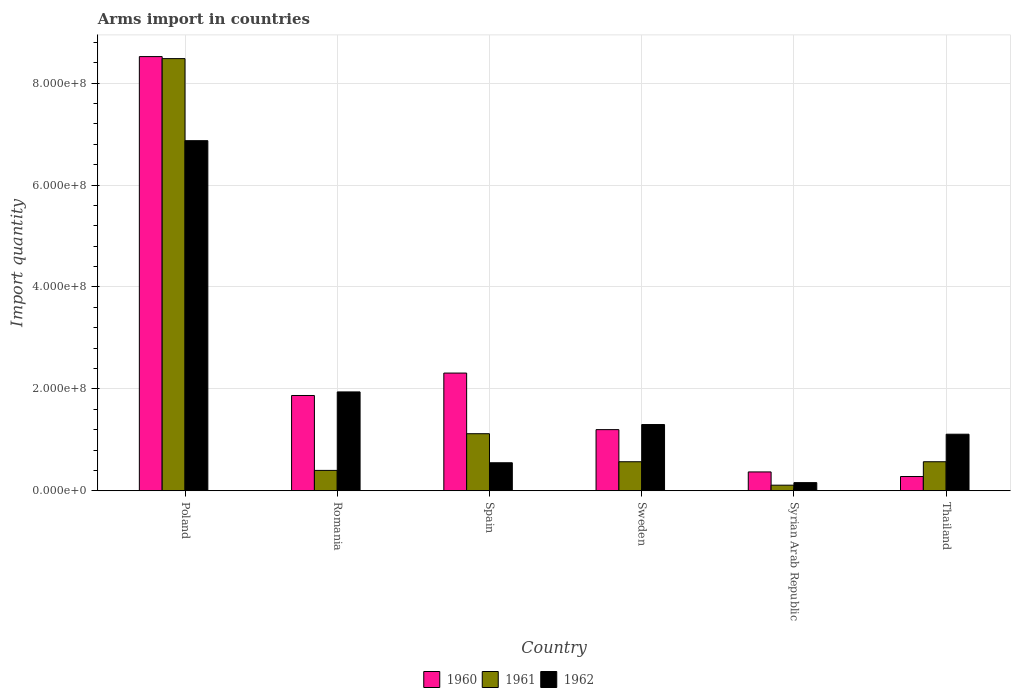How many groups of bars are there?
Your response must be concise. 6. Are the number of bars per tick equal to the number of legend labels?
Offer a very short reply. Yes. Are the number of bars on each tick of the X-axis equal?
Provide a short and direct response. Yes. How many bars are there on the 5th tick from the left?
Your response must be concise. 3. How many bars are there on the 6th tick from the right?
Your answer should be very brief. 3. What is the label of the 6th group of bars from the left?
Offer a very short reply. Thailand. What is the total arms import in 1961 in Syrian Arab Republic?
Your answer should be compact. 1.10e+07. Across all countries, what is the maximum total arms import in 1962?
Offer a terse response. 6.87e+08. Across all countries, what is the minimum total arms import in 1962?
Give a very brief answer. 1.60e+07. In which country was the total arms import in 1961 maximum?
Offer a very short reply. Poland. In which country was the total arms import in 1961 minimum?
Your answer should be very brief. Syrian Arab Republic. What is the total total arms import in 1960 in the graph?
Your answer should be compact. 1.46e+09. What is the difference between the total arms import in 1962 in Romania and that in Syrian Arab Republic?
Make the answer very short. 1.78e+08. What is the difference between the total arms import in 1961 in Thailand and the total arms import in 1962 in Syrian Arab Republic?
Ensure brevity in your answer.  4.10e+07. What is the average total arms import in 1961 per country?
Keep it short and to the point. 1.88e+08. What is the difference between the total arms import of/in 1961 and total arms import of/in 1962 in Romania?
Give a very brief answer. -1.54e+08. What is the ratio of the total arms import in 1961 in Poland to that in Sweden?
Ensure brevity in your answer.  14.88. Is the total arms import in 1962 in Poland less than that in Romania?
Provide a succinct answer. No. What is the difference between the highest and the second highest total arms import in 1960?
Your response must be concise. 6.65e+08. What is the difference between the highest and the lowest total arms import in 1961?
Your answer should be very brief. 8.37e+08. In how many countries, is the total arms import in 1962 greater than the average total arms import in 1962 taken over all countries?
Your answer should be compact. 1. Is the sum of the total arms import in 1961 in Syrian Arab Republic and Thailand greater than the maximum total arms import in 1962 across all countries?
Make the answer very short. No. What does the 2nd bar from the left in Romania represents?
Your answer should be very brief. 1961. Is it the case that in every country, the sum of the total arms import in 1962 and total arms import in 1960 is greater than the total arms import in 1961?
Offer a terse response. Yes. How many countries are there in the graph?
Offer a very short reply. 6. What is the difference between two consecutive major ticks on the Y-axis?
Give a very brief answer. 2.00e+08. Are the values on the major ticks of Y-axis written in scientific E-notation?
Provide a succinct answer. Yes. Where does the legend appear in the graph?
Ensure brevity in your answer.  Bottom center. How are the legend labels stacked?
Offer a terse response. Horizontal. What is the title of the graph?
Make the answer very short. Arms import in countries. What is the label or title of the X-axis?
Offer a terse response. Country. What is the label or title of the Y-axis?
Make the answer very short. Import quantity. What is the Import quantity in 1960 in Poland?
Offer a very short reply. 8.52e+08. What is the Import quantity of 1961 in Poland?
Keep it short and to the point. 8.48e+08. What is the Import quantity of 1962 in Poland?
Provide a succinct answer. 6.87e+08. What is the Import quantity of 1960 in Romania?
Give a very brief answer. 1.87e+08. What is the Import quantity in 1961 in Romania?
Offer a terse response. 4.00e+07. What is the Import quantity of 1962 in Romania?
Offer a terse response. 1.94e+08. What is the Import quantity in 1960 in Spain?
Give a very brief answer. 2.31e+08. What is the Import quantity of 1961 in Spain?
Your response must be concise. 1.12e+08. What is the Import quantity of 1962 in Spain?
Your answer should be very brief. 5.50e+07. What is the Import quantity in 1960 in Sweden?
Offer a terse response. 1.20e+08. What is the Import quantity of 1961 in Sweden?
Your answer should be compact. 5.70e+07. What is the Import quantity of 1962 in Sweden?
Give a very brief answer. 1.30e+08. What is the Import quantity of 1960 in Syrian Arab Republic?
Offer a terse response. 3.70e+07. What is the Import quantity in 1961 in Syrian Arab Republic?
Your answer should be very brief. 1.10e+07. What is the Import quantity of 1962 in Syrian Arab Republic?
Offer a terse response. 1.60e+07. What is the Import quantity of 1960 in Thailand?
Make the answer very short. 2.80e+07. What is the Import quantity of 1961 in Thailand?
Your answer should be very brief. 5.70e+07. What is the Import quantity of 1962 in Thailand?
Your answer should be very brief. 1.11e+08. Across all countries, what is the maximum Import quantity of 1960?
Provide a short and direct response. 8.52e+08. Across all countries, what is the maximum Import quantity of 1961?
Make the answer very short. 8.48e+08. Across all countries, what is the maximum Import quantity of 1962?
Offer a very short reply. 6.87e+08. Across all countries, what is the minimum Import quantity in 1960?
Keep it short and to the point. 2.80e+07. Across all countries, what is the minimum Import quantity of 1961?
Offer a very short reply. 1.10e+07. Across all countries, what is the minimum Import quantity in 1962?
Give a very brief answer. 1.60e+07. What is the total Import quantity of 1960 in the graph?
Your answer should be compact. 1.46e+09. What is the total Import quantity in 1961 in the graph?
Give a very brief answer. 1.12e+09. What is the total Import quantity in 1962 in the graph?
Offer a very short reply. 1.19e+09. What is the difference between the Import quantity in 1960 in Poland and that in Romania?
Your answer should be compact. 6.65e+08. What is the difference between the Import quantity in 1961 in Poland and that in Romania?
Your response must be concise. 8.08e+08. What is the difference between the Import quantity of 1962 in Poland and that in Romania?
Provide a short and direct response. 4.93e+08. What is the difference between the Import quantity of 1960 in Poland and that in Spain?
Your answer should be very brief. 6.21e+08. What is the difference between the Import quantity of 1961 in Poland and that in Spain?
Provide a succinct answer. 7.36e+08. What is the difference between the Import quantity of 1962 in Poland and that in Spain?
Give a very brief answer. 6.32e+08. What is the difference between the Import quantity in 1960 in Poland and that in Sweden?
Your answer should be very brief. 7.32e+08. What is the difference between the Import quantity in 1961 in Poland and that in Sweden?
Provide a succinct answer. 7.91e+08. What is the difference between the Import quantity of 1962 in Poland and that in Sweden?
Give a very brief answer. 5.57e+08. What is the difference between the Import quantity in 1960 in Poland and that in Syrian Arab Republic?
Offer a very short reply. 8.15e+08. What is the difference between the Import quantity of 1961 in Poland and that in Syrian Arab Republic?
Provide a succinct answer. 8.37e+08. What is the difference between the Import quantity of 1962 in Poland and that in Syrian Arab Republic?
Your answer should be compact. 6.71e+08. What is the difference between the Import quantity of 1960 in Poland and that in Thailand?
Provide a succinct answer. 8.24e+08. What is the difference between the Import quantity of 1961 in Poland and that in Thailand?
Your answer should be compact. 7.91e+08. What is the difference between the Import quantity of 1962 in Poland and that in Thailand?
Keep it short and to the point. 5.76e+08. What is the difference between the Import quantity in 1960 in Romania and that in Spain?
Provide a succinct answer. -4.40e+07. What is the difference between the Import quantity in 1961 in Romania and that in Spain?
Your response must be concise. -7.20e+07. What is the difference between the Import quantity in 1962 in Romania and that in Spain?
Give a very brief answer. 1.39e+08. What is the difference between the Import quantity in 1960 in Romania and that in Sweden?
Offer a terse response. 6.70e+07. What is the difference between the Import quantity in 1961 in Romania and that in Sweden?
Keep it short and to the point. -1.70e+07. What is the difference between the Import quantity in 1962 in Romania and that in Sweden?
Provide a short and direct response. 6.40e+07. What is the difference between the Import quantity of 1960 in Romania and that in Syrian Arab Republic?
Offer a very short reply. 1.50e+08. What is the difference between the Import quantity of 1961 in Romania and that in Syrian Arab Republic?
Provide a short and direct response. 2.90e+07. What is the difference between the Import quantity of 1962 in Romania and that in Syrian Arab Republic?
Ensure brevity in your answer.  1.78e+08. What is the difference between the Import quantity of 1960 in Romania and that in Thailand?
Offer a terse response. 1.59e+08. What is the difference between the Import quantity of 1961 in Romania and that in Thailand?
Ensure brevity in your answer.  -1.70e+07. What is the difference between the Import quantity of 1962 in Romania and that in Thailand?
Your answer should be very brief. 8.30e+07. What is the difference between the Import quantity in 1960 in Spain and that in Sweden?
Your answer should be compact. 1.11e+08. What is the difference between the Import quantity of 1961 in Spain and that in Sweden?
Your answer should be very brief. 5.50e+07. What is the difference between the Import quantity of 1962 in Spain and that in Sweden?
Offer a terse response. -7.50e+07. What is the difference between the Import quantity in 1960 in Spain and that in Syrian Arab Republic?
Your answer should be compact. 1.94e+08. What is the difference between the Import quantity of 1961 in Spain and that in Syrian Arab Republic?
Provide a succinct answer. 1.01e+08. What is the difference between the Import quantity of 1962 in Spain and that in Syrian Arab Republic?
Keep it short and to the point. 3.90e+07. What is the difference between the Import quantity of 1960 in Spain and that in Thailand?
Make the answer very short. 2.03e+08. What is the difference between the Import quantity of 1961 in Spain and that in Thailand?
Keep it short and to the point. 5.50e+07. What is the difference between the Import quantity of 1962 in Spain and that in Thailand?
Your response must be concise. -5.60e+07. What is the difference between the Import quantity of 1960 in Sweden and that in Syrian Arab Republic?
Your response must be concise. 8.30e+07. What is the difference between the Import quantity of 1961 in Sweden and that in Syrian Arab Republic?
Give a very brief answer. 4.60e+07. What is the difference between the Import quantity of 1962 in Sweden and that in Syrian Arab Republic?
Keep it short and to the point. 1.14e+08. What is the difference between the Import quantity of 1960 in Sweden and that in Thailand?
Provide a short and direct response. 9.20e+07. What is the difference between the Import quantity in 1962 in Sweden and that in Thailand?
Your response must be concise. 1.90e+07. What is the difference between the Import quantity in 1960 in Syrian Arab Republic and that in Thailand?
Keep it short and to the point. 9.00e+06. What is the difference between the Import quantity of 1961 in Syrian Arab Republic and that in Thailand?
Your answer should be very brief. -4.60e+07. What is the difference between the Import quantity of 1962 in Syrian Arab Republic and that in Thailand?
Keep it short and to the point. -9.50e+07. What is the difference between the Import quantity in 1960 in Poland and the Import quantity in 1961 in Romania?
Provide a short and direct response. 8.12e+08. What is the difference between the Import quantity in 1960 in Poland and the Import quantity in 1962 in Romania?
Make the answer very short. 6.58e+08. What is the difference between the Import quantity of 1961 in Poland and the Import quantity of 1962 in Romania?
Offer a terse response. 6.54e+08. What is the difference between the Import quantity of 1960 in Poland and the Import quantity of 1961 in Spain?
Provide a succinct answer. 7.40e+08. What is the difference between the Import quantity in 1960 in Poland and the Import quantity in 1962 in Spain?
Your response must be concise. 7.97e+08. What is the difference between the Import quantity of 1961 in Poland and the Import quantity of 1962 in Spain?
Ensure brevity in your answer.  7.93e+08. What is the difference between the Import quantity in 1960 in Poland and the Import quantity in 1961 in Sweden?
Make the answer very short. 7.95e+08. What is the difference between the Import quantity of 1960 in Poland and the Import quantity of 1962 in Sweden?
Your response must be concise. 7.22e+08. What is the difference between the Import quantity in 1961 in Poland and the Import quantity in 1962 in Sweden?
Offer a terse response. 7.18e+08. What is the difference between the Import quantity in 1960 in Poland and the Import quantity in 1961 in Syrian Arab Republic?
Your response must be concise. 8.41e+08. What is the difference between the Import quantity in 1960 in Poland and the Import quantity in 1962 in Syrian Arab Republic?
Your response must be concise. 8.36e+08. What is the difference between the Import quantity in 1961 in Poland and the Import quantity in 1962 in Syrian Arab Republic?
Offer a terse response. 8.32e+08. What is the difference between the Import quantity in 1960 in Poland and the Import quantity in 1961 in Thailand?
Ensure brevity in your answer.  7.95e+08. What is the difference between the Import quantity in 1960 in Poland and the Import quantity in 1962 in Thailand?
Provide a succinct answer. 7.41e+08. What is the difference between the Import quantity of 1961 in Poland and the Import quantity of 1962 in Thailand?
Make the answer very short. 7.37e+08. What is the difference between the Import quantity of 1960 in Romania and the Import quantity of 1961 in Spain?
Provide a succinct answer. 7.50e+07. What is the difference between the Import quantity in 1960 in Romania and the Import quantity in 1962 in Spain?
Provide a short and direct response. 1.32e+08. What is the difference between the Import quantity of 1961 in Romania and the Import quantity of 1962 in Spain?
Your answer should be compact. -1.50e+07. What is the difference between the Import quantity of 1960 in Romania and the Import quantity of 1961 in Sweden?
Give a very brief answer. 1.30e+08. What is the difference between the Import quantity of 1960 in Romania and the Import quantity of 1962 in Sweden?
Your response must be concise. 5.70e+07. What is the difference between the Import quantity of 1961 in Romania and the Import quantity of 1962 in Sweden?
Make the answer very short. -9.00e+07. What is the difference between the Import quantity of 1960 in Romania and the Import quantity of 1961 in Syrian Arab Republic?
Ensure brevity in your answer.  1.76e+08. What is the difference between the Import quantity in 1960 in Romania and the Import quantity in 1962 in Syrian Arab Republic?
Give a very brief answer. 1.71e+08. What is the difference between the Import quantity of 1961 in Romania and the Import quantity of 1962 in Syrian Arab Republic?
Ensure brevity in your answer.  2.40e+07. What is the difference between the Import quantity in 1960 in Romania and the Import quantity in 1961 in Thailand?
Keep it short and to the point. 1.30e+08. What is the difference between the Import quantity of 1960 in Romania and the Import quantity of 1962 in Thailand?
Provide a succinct answer. 7.60e+07. What is the difference between the Import quantity in 1961 in Romania and the Import quantity in 1962 in Thailand?
Your answer should be very brief. -7.10e+07. What is the difference between the Import quantity in 1960 in Spain and the Import quantity in 1961 in Sweden?
Keep it short and to the point. 1.74e+08. What is the difference between the Import quantity in 1960 in Spain and the Import quantity in 1962 in Sweden?
Provide a succinct answer. 1.01e+08. What is the difference between the Import quantity of 1961 in Spain and the Import quantity of 1962 in Sweden?
Provide a short and direct response. -1.80e+07. What is the difference between the Import quantity of 1960 in Spain and the Import quantity of 1961 in Syrian Arab Republic?
Your answer should be compact. 2.20e+08. What is the difference between the Import quantity in 1960 in Spain and the Import quantity in 1962 in Syrian Arab Republic?
Make the answer very short. 2.15e+08. What is the difference between the Import quantity of 1961 in Spain and the Import quantity of 1962 in Syrian Arab Republic?
Make the answer very short. 9.60e+07. What is the difference between the Import quantity in 1960 in Spain and the Import quantity in 1961 in Thailand?
Your answer should be very brief. 1.74e+08. What is the difference between the Import quantity in 1960 in Spain and the Import quantity in 1962 in Thailand?
Offer a terse response. 1.20e+08. What is the difference between the Import quantity in 1960 in Sweden and the Import quantity in 1961 in Syrian Arab Republic?
Offer a terse response. 1.09e+08. What is the difference between the Import quantity of 1960 in Sweden and the Import quantity of 1962 in Syrian Arab Republic?
Keep it short and to the point. 1.04e+08. What is the difference between the Import quantity in 1961 in Sweden and the Import quantity in 1962 in Syrian Arab Republic?
Give a very brief answer. 4.10e+07. What is the difference between the Import quantity of 1960 in Sweden and the Import quantity of 1961 in Thailand?
Offer a terse response. 6.30e+07. What is the difference between the Import quantity in 1960 in Sweden and the Import quantity in 1962 in Thailand?
Offer a very short reply. 9.00e+06. What is the difference between the Import quantity of 1961 in Sweden and the Import quantity of 1962 in Thailand?
Ensure brevity in your answer.  -5.40e+07. What is the difference between the Import quantity in 1960 in Syrian Arab Republic and the Import quantity in 1961 in Thailand?
Your answer should be very brief. -2.00e+07. What is the difference between the Import quantity in 1960 in Syrian Arab Republic and the Import quantity in 1962 in Thailand?
Offer a very short reply. -7.40e+07. What is the difference between the Import quantity of 1961 in Syrian Arab Republic and the Import quantity of 1962 in Thailand?
Offer a terse response. -1.00e+08. What is the average Import quantity of 1960 per country?
Provide a succinct answer. 2.42e+08. What is the average Import quantity of 1961 per country?
Provide a succinct answer. 1.88e+08. What is the average Import quantity of 1962 per country?
Keep it short and to the point. 1.99e+08. What is the difference between the Import quantity in 1960 and Import quantity in 1961 in Poland?
Provide a short and direct response. 4.00e+06. What is the difference between the Import quantity in 1960 and Import quantity in 1962 in Poland?
Keep it short and to the point. 1.65e+08. What is the difference between the Import quantity in 1961 and Import quantity in 1962 in Poland?
Your answer should be very brief. 1.61e+08. What is the difference between the Import quantity in 1960 and Import quantity in 1961 in Romania?
Offer a very short reply. 1.47e+08. What is the difference between the Import quantity in 1960 and Import quantity in 1962 in Romania?
Your response must be concise. -7.00e+06. What is the difference between the Import quantity of 1961 and Import quantity of 1962 in Romania?
Provide a short and direct response. -1.54e+08. What is the difference between the Import quantity in 1960 and Import quantity in 1961 in Spain?
Your answer should be very brief. 1.19e+08. What is the difference between the Import quantity of 1960 and Import quantity of 1962 in Spain?
Your answer should be very brief. 1.76e+08. What is the difference between the Import quantity of 1961 and Import quantity of 1962 in Spain?
Your response must be concise. 5.70e+07. What is the difference between the Import quantity of 1960 and Import quantity of 1961 in Sweden?
Make the answer very short. 6.30e+07. What is the difference between the Import quantity of 1960 and Import quantity of 1962 in Sweden?
Provide a short and direct response. -1.00e+07. What is the difference between the Import quantity in 1961 and Import quantity in 1962 in Sweden?
Ensure brevity in your answer.  -7.30e+07. What is the difference between the Import quantity in 1960 and Import quantity in 1961 in Syrian Arab Republic?
Your answer should be very brief. 2.60e+07. What is the difference between the Import quantity in 1960 and Import quantity in 1962 in Syrian Arab Republic?
Offer a terse response. 2.10e+07. What is the difference between the Import quantity of 1961 and Import quantity of 1962 in Syrian Arab Republic?
Provide a short and direct response. -5.00e+06. What is the difference between the Import quantity in 1960 and Import quantity in 1961 in Thailand?
Your answer should be compact. -2.90e+07. What is the difference between the Import quantity of 1960 and Import quantity of 1962 in Thailand?
Ensure brevity in your answer.  -8.30e+07. What is the difference between the Import quantity of 1961 and Import quantity of 1962 in Thailand?
Make the answer very short. -5.40e+07. What is the ratio of the Import quantity of 1960 in Poland to that in Romania?
Offer a very short reply. 4.56. What is the ratio of the Import quantity in 1961 in Poland to that in Romania?
Your answer should be very brief. 21.2. What is the ratio of the Import quantity in 1962 in Poland to that in Romania?
Ensure brevity in your answer.  3.54. What is the ratio of the Import quantity in 1960 in Poland to that in Spain?
Your answer should be very brief. 3.69. What is the ratio of the Import quantity of 1961 in Poland to that in Spain?
Your answer should be very brief. 7.57. What is the ratio of the Import quantity in 1962 in Poland to that in Spain?
Your response must be concise. 12.49. What is the ratio of the Import quantity of 1960 in Poland to that in Sweden?
Make the answer very short. 7.1. What is the ratio of the Import quantity of 1961 in Poland to that in Sweden?
Your response must be concise. 14.88. What is the ratio of the Import quantity of 1962 in Poland to that in Sweden?
Offer a terse response. 5.28. What is the ratio of the Import quantity in 1960 in Poland to that in Syrian Arab Republic?
Your response must be concise. 23.03. What is the ratio of the Import quantity in 1961 in Poland to that in Syrian Arab Republic?
Ensure brevity in your answer.  77.09. What is the ratio of the Import quantity of 1962 in Poland to that in Syrian Arab Republic?
Your response must be concise. 42.94. What is the ratio of the Import quantity in 1960 in Poland to that in Thailand?
Your answer should be very brief. 30.43. What is the ratio of the Import quantity of 1961 in Poland to that in Thailand?
Your answer should be very brief. 14.88. What is the ratio of the Import quantity in 1962 in Poland to that in Thailand?
Your answer should be compact. 6.19. What is the ratio of the Import quantity in 1960 in Romania to that in Spain?
Offer a very short reply. 0.81. What is the ratio of the Import quantity in 1961 in Romania to that in Spain?
Make the answer very short. 0.36. What is the ratio of the Import quantity of 1962 in Romania to that in Spain?
Your answer should be very brief. 3.53. What is the ratio of the Import quantity in 1960 in Romania to that in Sweden?
Provide a succinct answer. 1.56. What is the ratio of the Import quantity in 1961 in Romania to that in Sweden?
Provide a short and direct response. 0.7. What is the ratio of the Import quantity of 1962 in Romania to that in Sweden?
Keep it short and to the point. 1.49. What is the ratio of the Import quantity of 1960 in Romania to that in Syrian Arab Republic?
Your answer should be compact. 5.05. What is the ratio of the Import quantity of 1961 in Romania to that in Syrian Arab Republic?
Your answer should be very brief. 3.64. What is the ratio of the Import quantity of 1962 in Romania to that in Syrian Arab Republic?
Your response must be concise. 12.12. What is the ratio of the Import quantity of 1960 in Romania to that in Thailand?
Offer a terse response. 6.68. What is the ratio of the Import quantity of 1961 in Romania to that in Thailand?
Ensure brevity in your answer.  0.7. What is the ratio of the Import quantity in 1962 in Romania to that in Thailand?
Your response must be concise. 1.75. What is the ratio of the Import quantity of 1960 in Spain to that in Sweden?
Your response must be concise. 1.93. What is the ratio of the Import quantity in 1961 in Spain to that in Sweden?
Your answer should be compact. 1.96. What is the ratio of the Import quantity of 1962 in Spain to that in Sweden?
Your answer should be compact. 0.42. What is the ratio of the Import quantity of 1960 in Spain to that in Syrian Arab Republic?
Keep it short and to the point. 6.24. What is the ratio of the Import quantity of 1961 in Spain to that in Syrian Arab Republic?
Give a very brief answer. 10.18. What is the ratio of the Import quantity in 1962 in Spain to that in Syrian Arab Republic?
Your response must be concise. 3.44. What is the ratio of the Import quantity of 1960 in Spain to that in Thailand?
Make the answer very short. 8.25. What is the ratio of the Import quantity in 1961 in Spain to that in Thailand?
Your response must be concise. 1.96. What is the ratio of the Import quantity in 1962 in Spain to that in Thailand?
Your answer should be compact. 0.5. What is the ratio of the Import quantity of 1960 in Sweden to that in Syrian Arab Republic?
Provide a short and direct response. 3.24. What is the ratio of the Import quantity of 1961 in Sweden to that in Syrian Arab Republic?
Your answer should be compact. 5.18. What is the ratio of the Import quantity of 1962 in Sweden to that in Syrian Arab Republic?
Keep it short and to the point. 8.12. What is the ratio of the Import quantity in 1960 in Sweden to that in Thailand?
Offer a terse response. 4.29. What is the ratio of the Import quantity in 1962 in Sweden to that in Thailand?
Your answer should be very brief. 1.17. What is the ratio of the Import quantity in 1960 in Syrian Arab Republic to that in Thailand?
Offer a very short reply. 1.32. What is the ratio of the Import quantity of 1961 in Syrian Arab Republic to that in Thailand?
Offer a very short reply. 0.19. What is the ratio of the Import quantity of 1962 in Syrian Arab Republic to that in Thailand?
Your answer should be very brief. 0.14. What is the difference between the highest and the second highest Import quantity in 1960?
Offer a terse response. 6.21e+08. What is the difference between the highest and the second highest Import quantity in 1961?
Provide a short and direct response. 7.36e+08. What is the difference between the highest and the second highest Import quantity of 1962?
Your response must be concise. 4.93e+08. What is the difference between the highest and the lowest Import quantity of 1960?
Your response must be concise. 8.24e+08. What is the difference between the highest and the lowest Import quantity of 1961?
Provide a succinct answer. 8.37e+08. What is the difference between the highest and the lowest Import quantity of 1962?
Provide a short and direct response. 6.71e+08. 